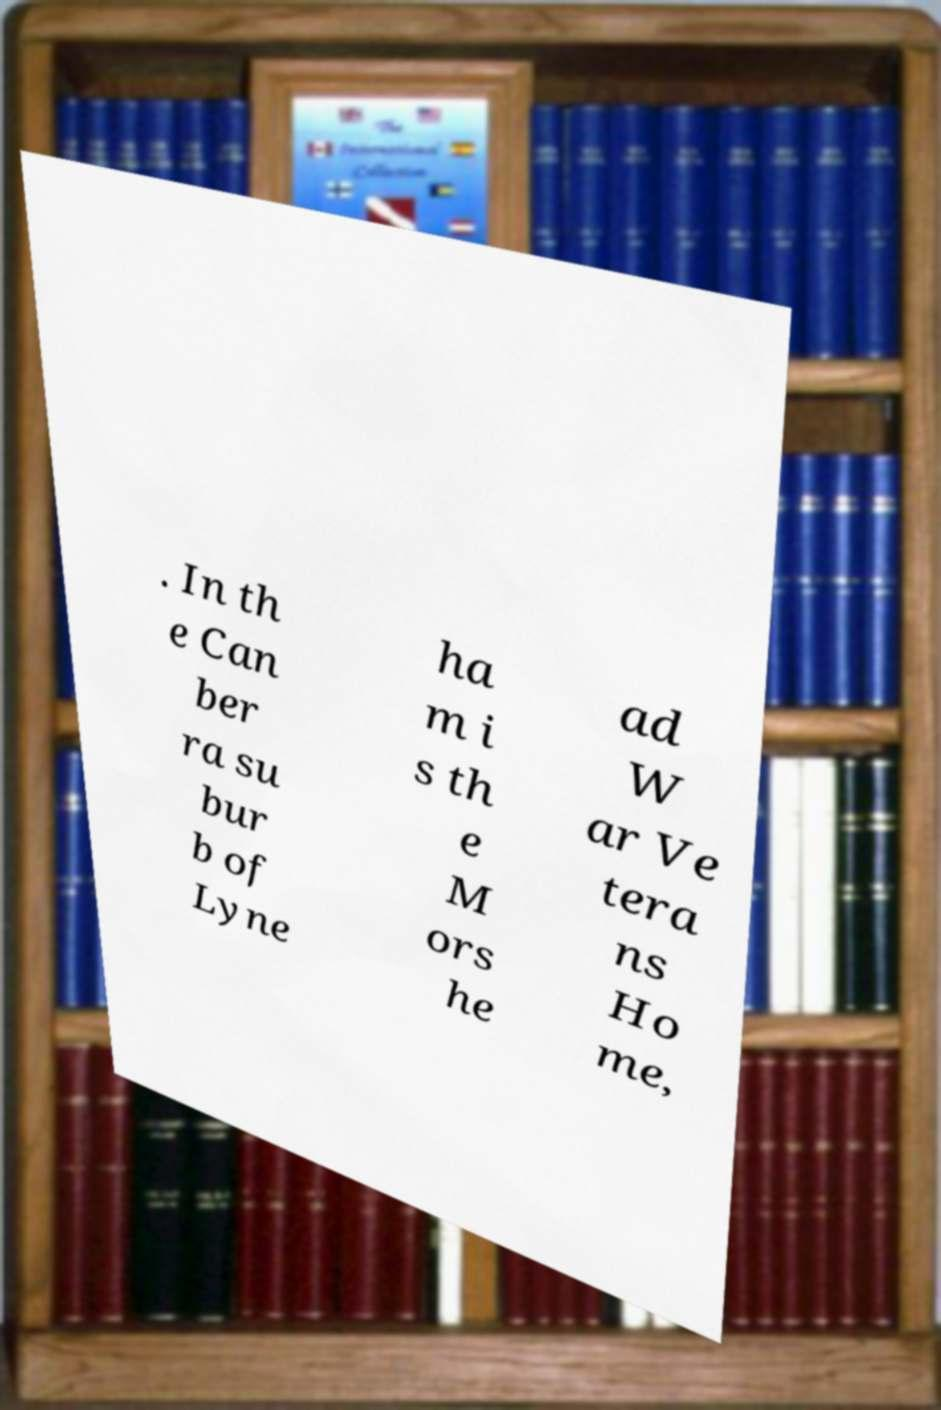Can you read and provide the text displayed in the image?This photo seems to have some interesting text. Can you extract and type it out for me? . In th e Can ber ra su bur b of Lyne ha m i s th e M ors he ad W ar Ve tera ns Ho me, 